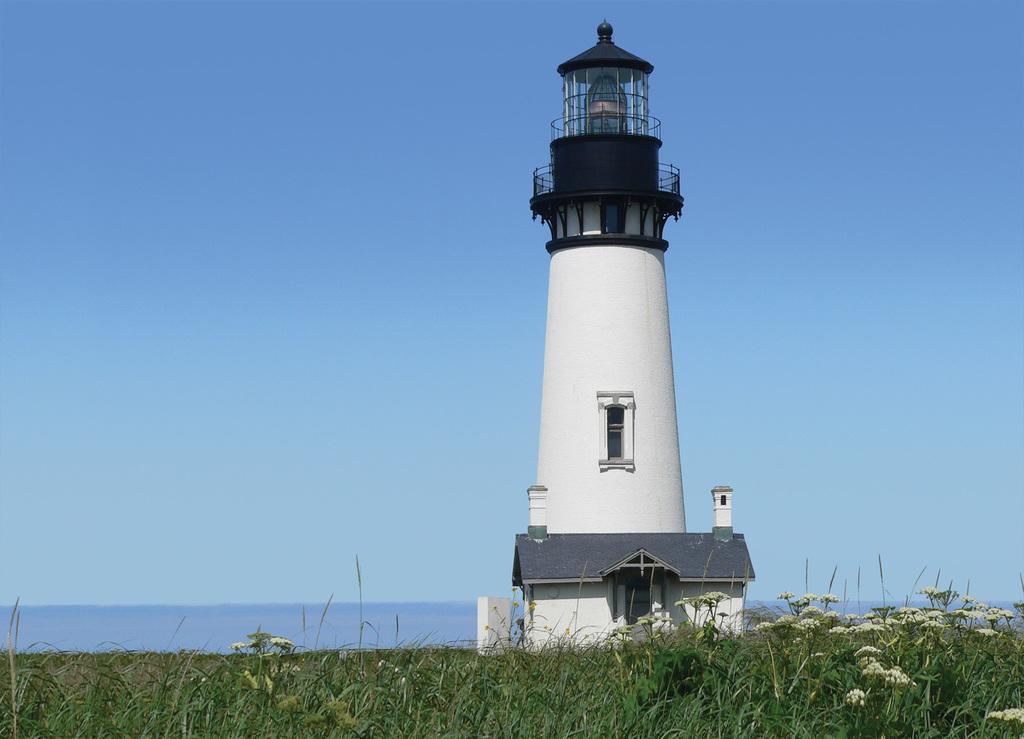Describe this image in one or two sentences. In this picture we can see the light tower. At the bottom we can see farmland, plant and flowers. In the background we can see the ocean. At the top there is a sky. 